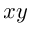<formula> <loc_0><loc_0><loc_500><loc_500>x y</formula> 